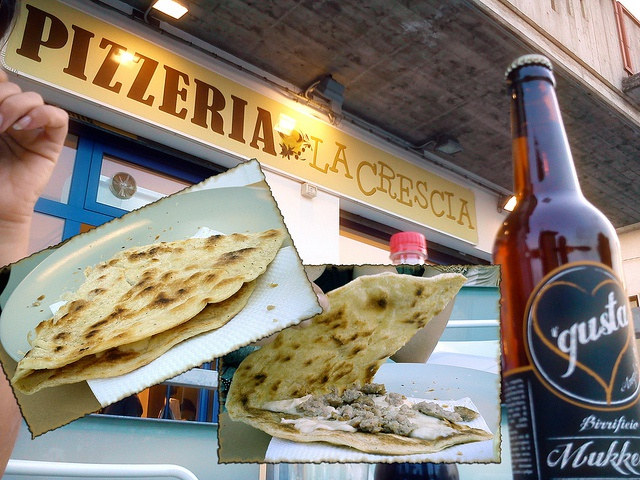Describe the objects in this image and their specific colors. I can see bottle in black, maroon, and gray tones, sandwich in black, tan, darkgray, olive, and lightgray tones, pizza in black, khaki, tan, and olive tones, people in black, lightpink, brown, maroon, and salmon tones, and bottle in black, salmon, lightpink, and lavender tones in this image. 